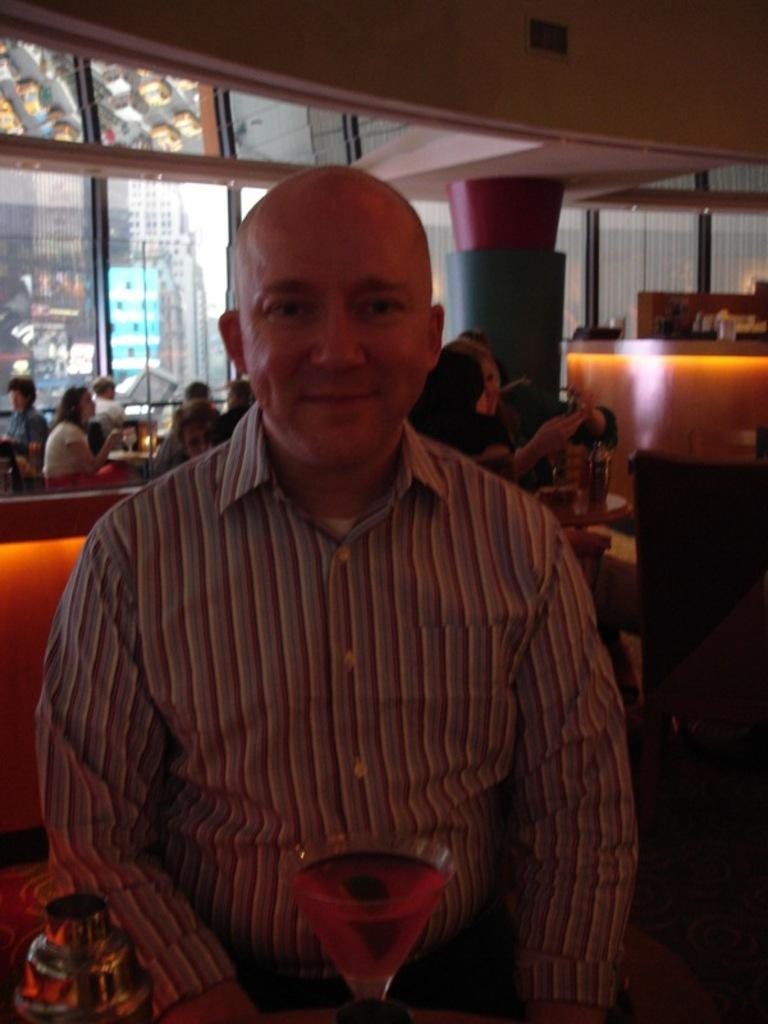What is the main subject of the image? There is a man in the image. What is the man wearing? The man is wearing a shirt. What is the man doing in the image? The man is sitting. What can be seen near the man? There is a glass of drink in the image. What is the man's facial expression? The man has a smile on his face. What can be seen in the background of the image? There are people in the background of the image. What type of brass instrument is the man playing in the image? There is no brass instrument present in the image; the man is simply sitting with a smile on his face. How many toes can be seen on the man's feet in the image? The image does not show the man's feet, so it is impossible to determine the number of toes. 